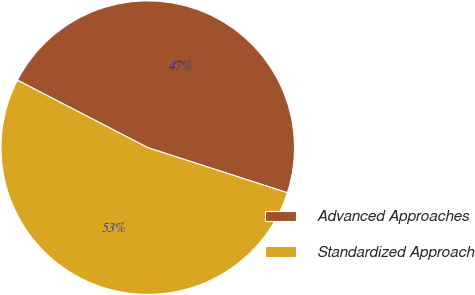<chart> <loc_0><loc_0><loc_500><loc_500><pie_chart><fcel>Advanced Approaches<fcel>Standardized Approach<nl><fcel>47.37%<fcel>52.63%<nl></chart> 